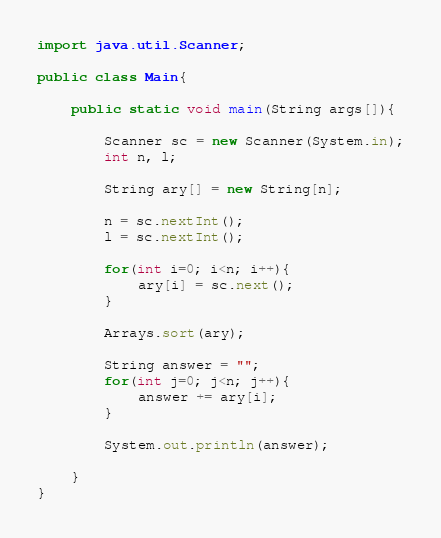<code> <loc_0><loc_0><loc_500><loc_500><_Java_>import java.util.Scanner;

public class Main{

	public static void main(String args[]){
    	
      	Scanner sc = new Scanner(System.in);
        int n, l;
      	
      	String ary[] = new String[n];
        
		n = sc.nextInt();
      	l = sc.nextInt();
      
      	for(int i=0; i<n; i++){
        	ary[i] = sc.next();
        }
      
      	Arrays.sort(ary);
      
      	String answer = "";
      	for(int j=0; j<n; j++){
        	answer += ary[i];
        }
      
      	System.out.println(answer);
        
    }
}</code> 